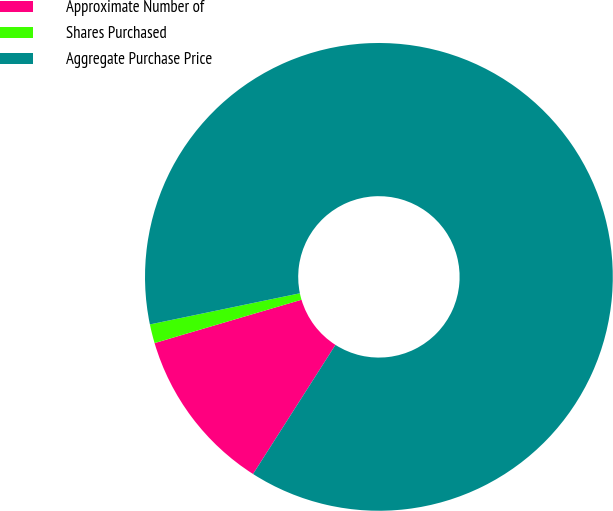Convert chart to OTSL. <chart><loc_0><loc_0><loc_500><loc_500><pie_chart><fcel>Approximate Number of<fcel>Shares Purchased<fcel>Aggregate Purchase Price<nl><fcel>11.39%<fcel>1.31%<fcel>87.3%<nl></chart> 